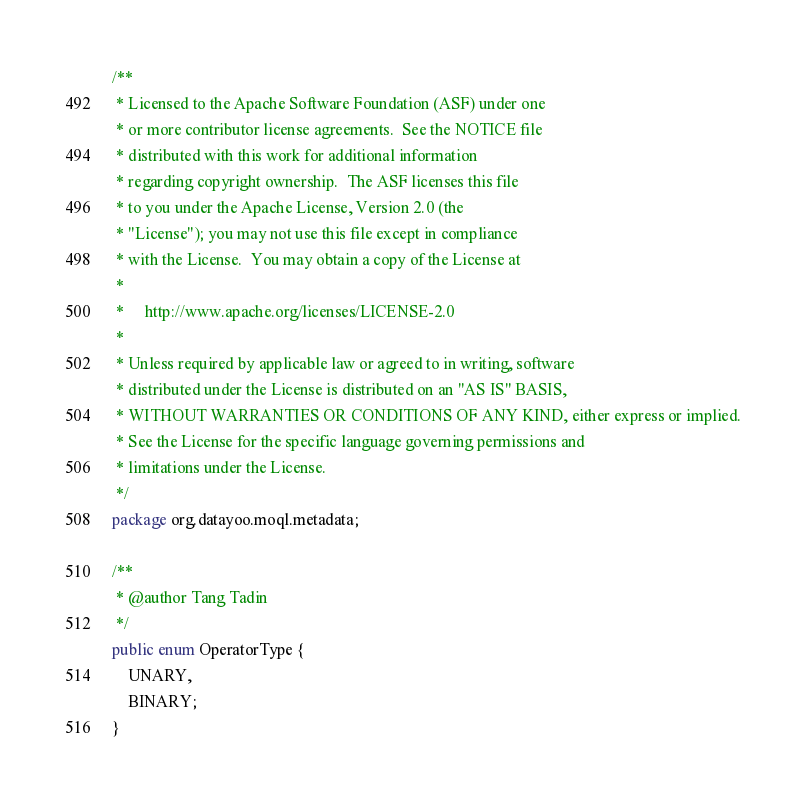Convert code to text. <code><loc_0><loc_0><loc_500><loc_500><_Java_>/**
 * Licensed to the Apache Software Foundation (ASF) under one
 * or more contributor license agreements.  See the NOTICE file
 * distributed with this work for additional information
 * regarding copyright ownership.  The ASF licenses this file
 * to you under the Apache License, Version 2.0 (the
 * "License"); you may not use this file except in compliance
 * with the License.  You may obtain a copy of the License at
 *
 *     http://www.apache.org/licenses/LICENSE-2.0
 *
 * Unless required by applicable law or agreed to in writing, software
 * distributed under the License is distributed on an "AS IS" BASIS,
 * WITHOUT WARRANTIES OR CONDITIONS OF ANY KIND, either express or implied.
 * See the License for the specific language governing permissions and
 * limitations under the License.
 */
package org.datayoo.moql.metadata;

/**
 * @author Tang Tadin
 */
public enum OperatorType {
	UNARY,
	BINARY;
}
</code> 